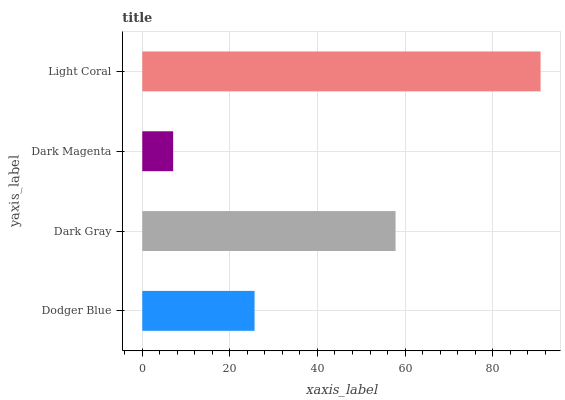Is Dark Magenta the minimum?
Answer yes or no. Yes. Is Light Coral the maximum?
Answer yes or no. Yes. Is Dark Gray the minimum?
Answer yes or no. No. Is Dark Gray the maximum?
Answer yes or no. No. Is Dark Gray greater than Dodger Blue?
Answer yes or no. Yes. Is Dodger Blue less than Dark Gray?
Answer yes or no. Yes. Is Dodger Blue greater than Dark Gray?
Answer yes or no. No. Is Dark Gray less than Dodger Blue?
Answer yes or no. No. Is Dark Gray the high median?
Answer yes or no. Yes. Is Dodger Blue the low median?
Answer yes or no. Yes. Is Dodger Blue the high median?
Answer yes or no. No. Is Dark Magenta the low median?
Answer yes or no. No. 